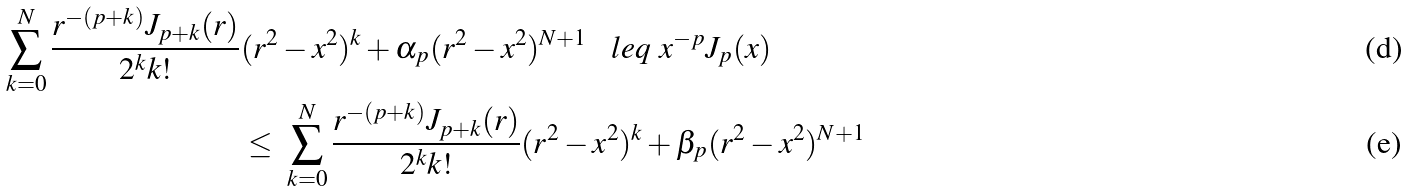<formula> <loc_0><loc_0><loc_500><loc_500>\sum _ { k = 0 } ^ { N } \frac { r ^ { - ( p + k ) } J _ { p + k } ( r ) } { 2 ^ { k } k ! } & ( r ^ { 2 } - x ^ { 2 } ) ^ { k } + \alpha _ { p } ( r ^ { 2 } - x ^ { 2 } ) ^ { N + 1 } \ \ \ l e q \ x ^ { - p } J _ { p } ( x ) \\ & \leq \ \sum _ { k = 0 } ^ { N } \frac { r ^ { - ( p + k ) } J _ { p + k } ( r ) } { 2 ^ { k } k ! } ( r ^ { 2 } - x ^ { 2 } ) ^ { k } + \beta _ { p } ( r ^ { 2 } - x ^ { 2 } ) ^ { N + 1 }</formula> 